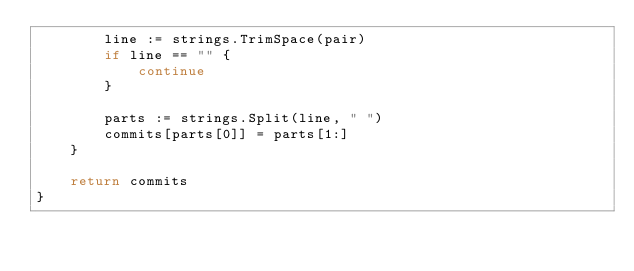<code> <loc_0><loc_0><loc_500><loc_500><_Go_>		line := strings.TrimSpace(pair)
		if line == "" {
			continue
		}

		parts := strings.Split(line, " ")
		commits[parts[0]] = parts[1:]
	}

	return commits
}
</code> 